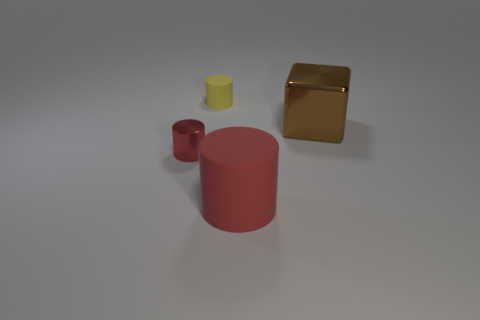There is a red thing to the right of the red thing that is behind the large cylinder; what is its shape?
Offer a terse response. Cylinder. Is the material of the small cylinder that is in front of the yellow object the same as the brown object?
Offer a very short reply. Yes. What number of cyan objects are either cylinders or tiny rubber things?
Ensure brevity in your answer.  0. Are there any tiny things that have the same color as the large matte thing?
Give a very brief answer. Yes. Is there a big brown object that has the same material as the block?
Ensure brevity in your answer.  No. What is the shape of the object that is both on the left side of the red matte cylinder and in front of the yellow rubber cylinder?
Give a very brief answer. Cylinder. What number of tiny objects are either red balls or matte objects?
Ensure brevity in your answer.  1. What is the small red cylinder made of?
Offer a terse response. Metal. What number of other objects are the same shape as the small yellow rubber thing?
Provide a succinct answer. 2. What is the size of the brown metallic thing?
Your answer should be very brief. Large. 